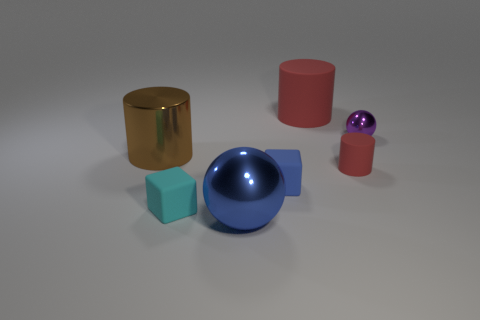Add 2 tiny green rubber spheres. How many objects exist? 9 Subtract all cubes. How many objects are left? 5 Add 6 purple things. How many purple things are left? 7 Add 6 large blue metal balls. How many large blue metal balls exist? 7 Subtract 0 yellow cubes. How many objects are left? 7 Subtract all small matte cylinders. Subtract all small cubes. How many objects are left? 4 